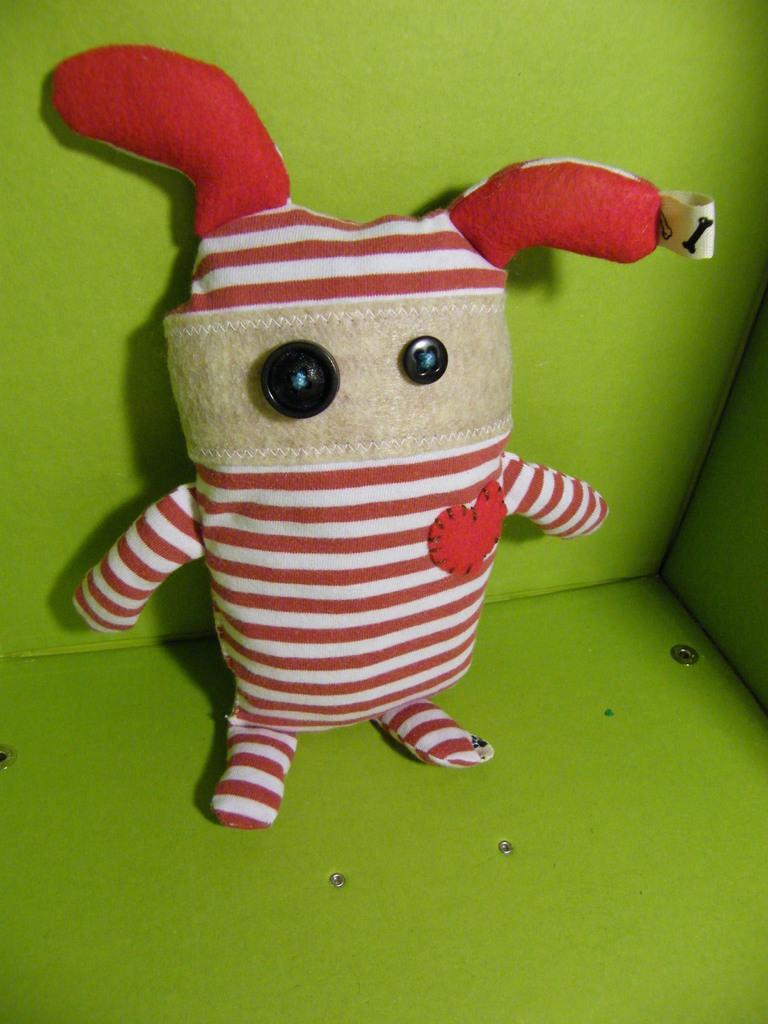How would you summarize this image in a sentence or two? In this picture we can see a toy with buttons on it and in the background we can see green wall. 